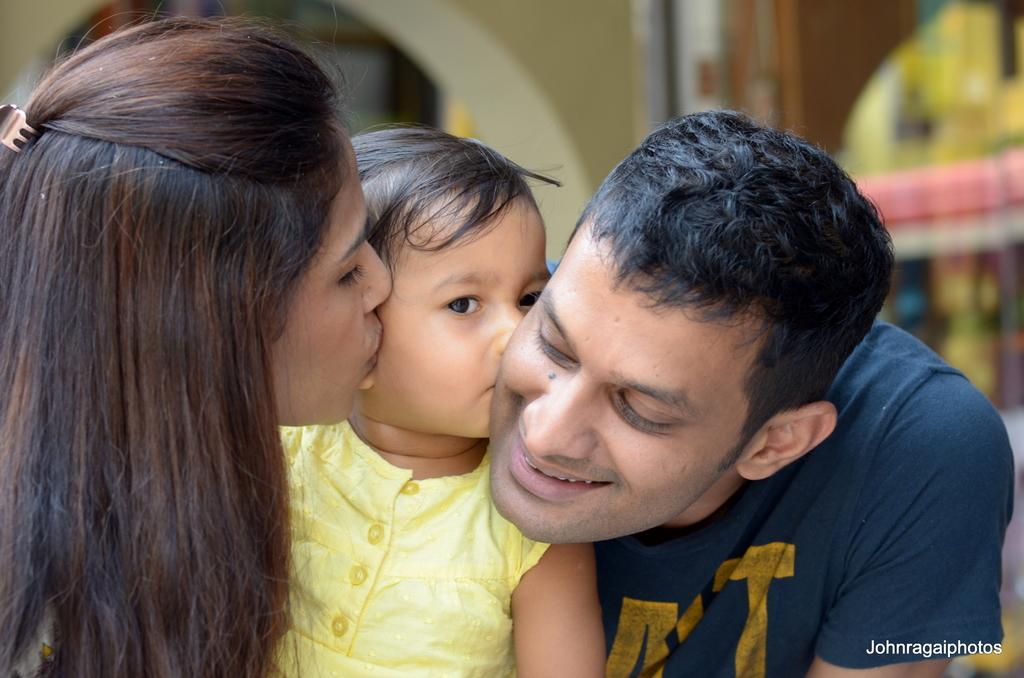In one or two sentences, can you explain what this image depicts? In this image I see woman who is kissing this child and I see that this child is kissing this man and I see that this man is smiling and I see the watermark over here and it blurred in the background. 